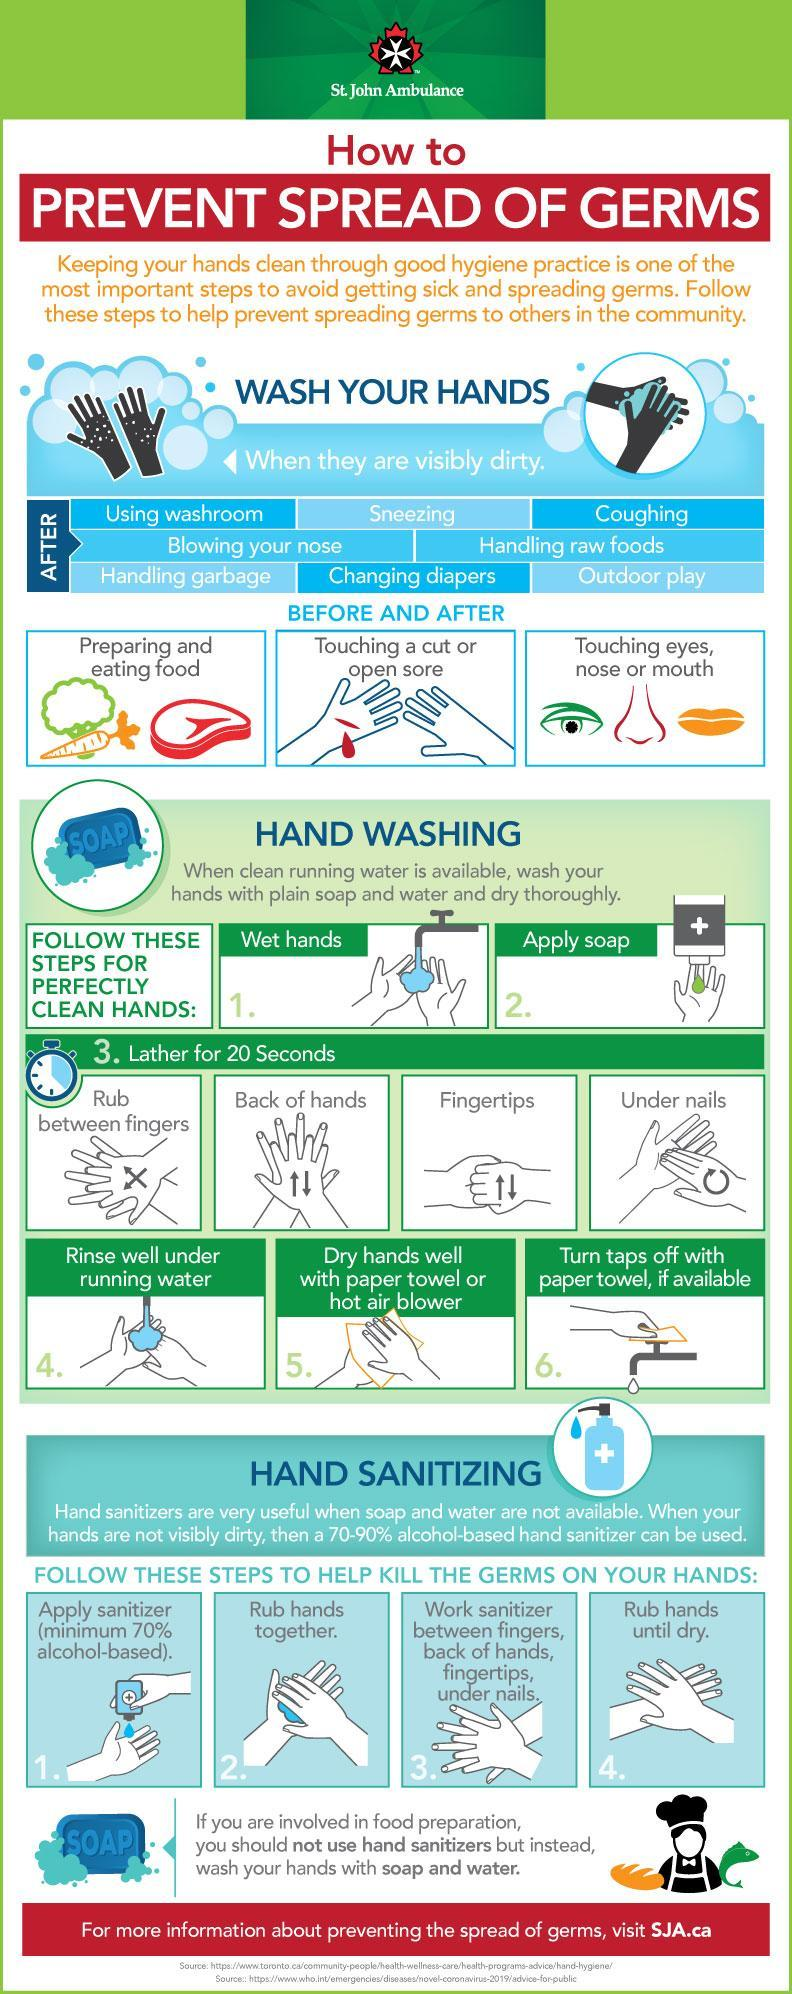How many parts of the face are in this infographic?
Answer the question with a short phrase. 3 How many types of handwashing in the step "Lather for 20 seconds? 4 How many steps are there to prevent the spread of germs? 2 Which parts of the face are in this infographic? eyes, nose, mouth 